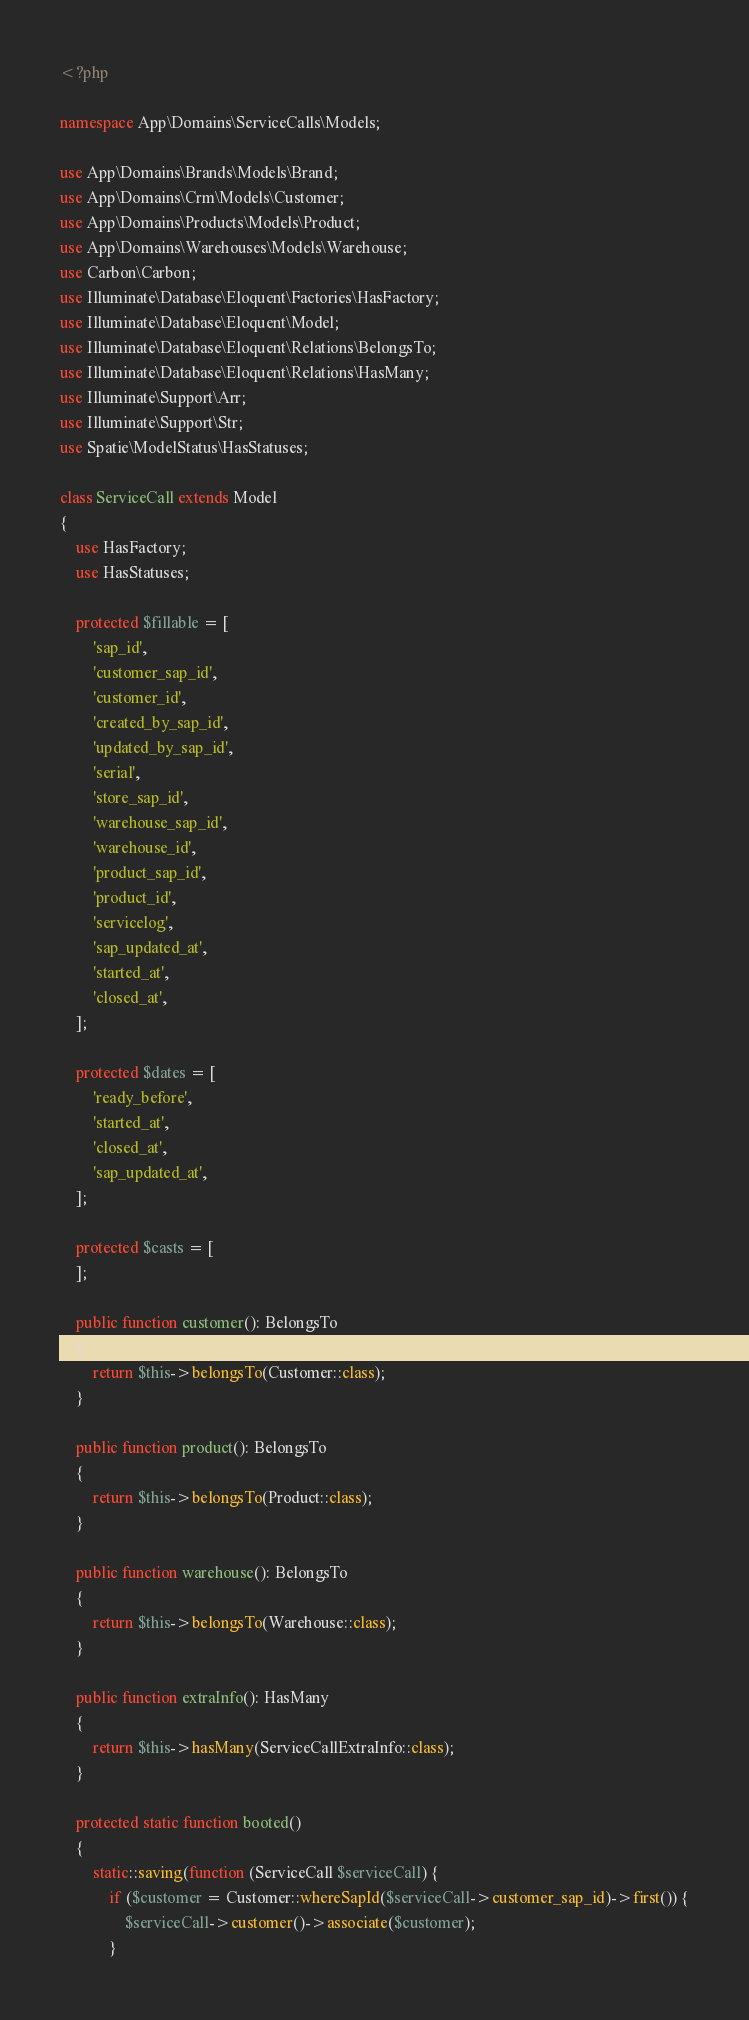<code> <loc_0><loc_0><loc_500><loc_500><_PHP_><?php

namespace App\Domains\ServiceCalls\Models;

use App\Domains\Brands\Models\Brand;
use App\Domains\Crm\Models\Customer;
use App\Domains\Products\Models\Product;
use App\Domains\Warehouses\Models\Warehouse;
use Carbon\Carbon;
use Illuminate\Database\Eloquent\Factories\HasFactory;
use Illuminate\Database\Eloquent\Model;
use Illuminate\Database\Eloquent\Relations\BelongsTo;
use Illuminate\Database\Eloquent\Relations\HasMany;
use Illuminate\Support\Arr;
use Illuminate\Support\Str;
use Spatie\ModelStatus\HasStatuses;

class ServiceCall extends Model
{
    use HasFactory;
    use HasStatuses;

    protected $fillable = [
        'sap_id',
        'customer_sap_id',
        'customer_id',
        'created_by_sap_id',
        'updated_by_sap_id',
        'serial',
        'store_sap_id',
        'warehouse_sap_id',
        'warehouse_id',
        'product_sap_id',
        'product_id',
        'servicelog',
        'sap_updated_at',
        'started_at',
        'closed_at',
    ];

    protected $dates = [
        'ready_before',
        'started_at',
        'closed_at',
        'sap_updated_at',
    ];

    protected $casts = [
    ];

    public function customer(): BelongsTo
    {
        return $this->belongsTo(Customer::class);
    }

    public function product(): BelongsTo
    {
        return $this->belongsTo(Product::class);
    }

    public function warehouse(): BelongsTo
    {
        return $this->belongsTo(Warehouse::class);
    }

    public function extraInfo(): HasMany
    {
        return $this->hasMany(ServiceCallExtraInfo::class);
    }

    protected static function booted()
    {
        static::saving(function (ServiceCall $serviceCall) {
            if ($customer = Customer::whereSapId($serviceCall->customer_sap_id)->first()) {
                $serviceCall->customer()->associate($customer);
            }</code> 